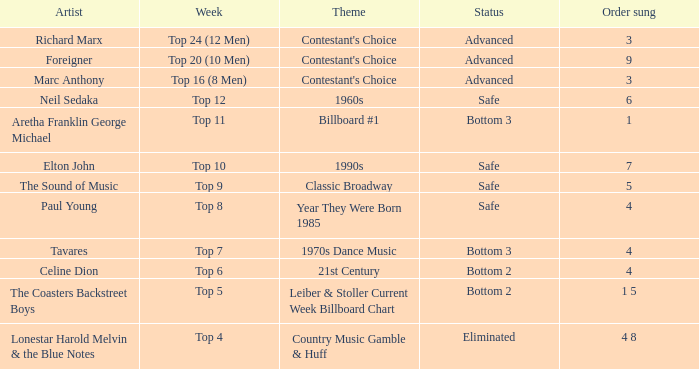What was the theme for the Top 11 week? Billboard #1. 